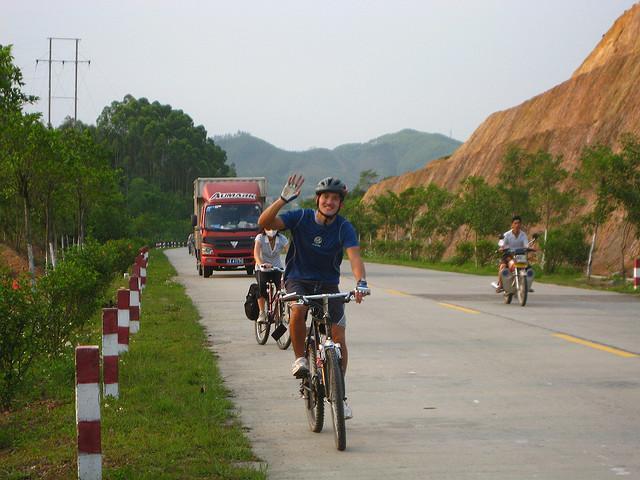How many bicycles are there?
Give a very brief answer. 3. How many bikes are here?
Give a very brief answer. 3. 